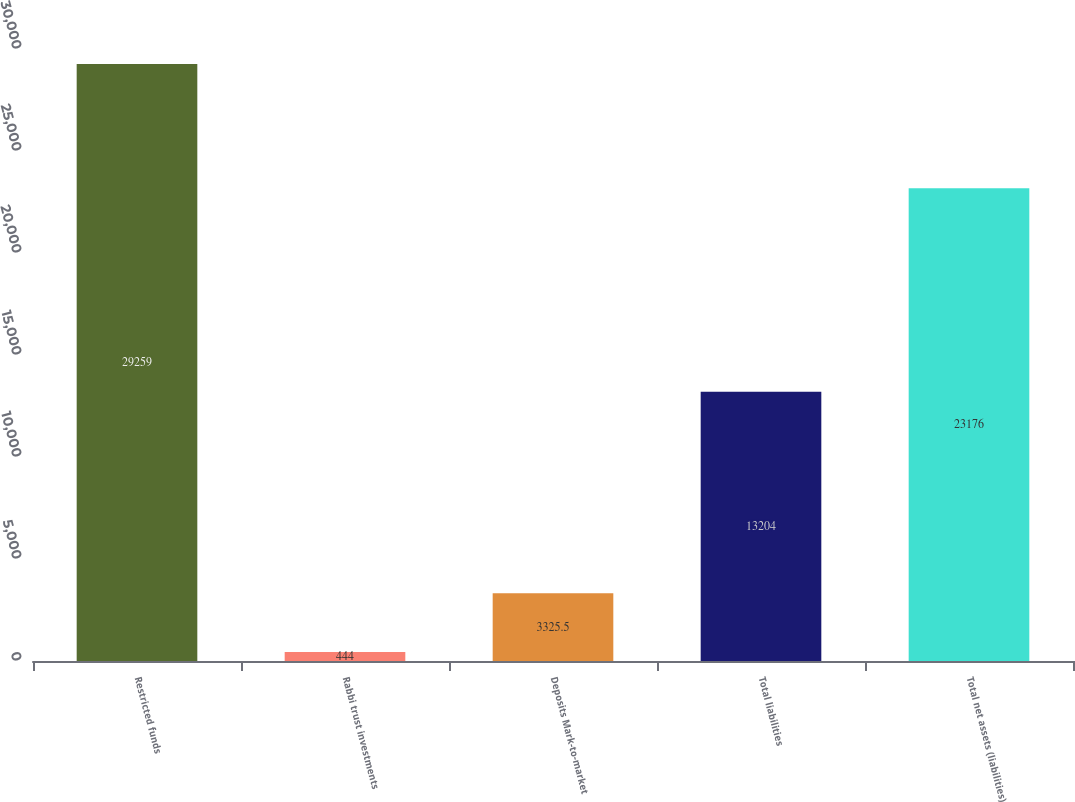Convert chart. <chart><loc_0><loc_0><loc_500><loc_500><bar_chart><fcel>Restricted funds<fcel>Rabbi trust investments<fcel>Deposits Mark-to-market<fcel>Total liabilities<fcel>Total net assets (liabilities)<nl><fcel>29259<fcel>444<fcel>3325.5<fcel>13204<fcel>23176<nl></chart> 